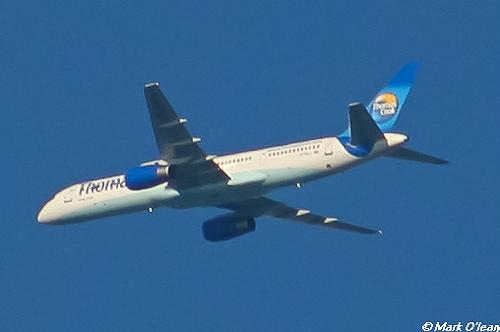Question: who took the photo?
Choices:
A. George.
B. Caroline.
C. Alice.
D. Max.
Answer with the letter. Answer: D Question: when was the photo taken?
Choices:
A. Today.
B. Yesterday.
C. Last week.
D. In 1902.
Answer with the letter. Answer: B 